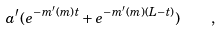Convert formula to latex. <formula><loc_0><loc_0><loc_500><loc_500>a ^ { \prime } ( e ^ { - m ^ { \prime } ( m ) t } + e ^ { - m ^ { \prime } ( m ) ( L - t ) } ) \quad ,</formula> 